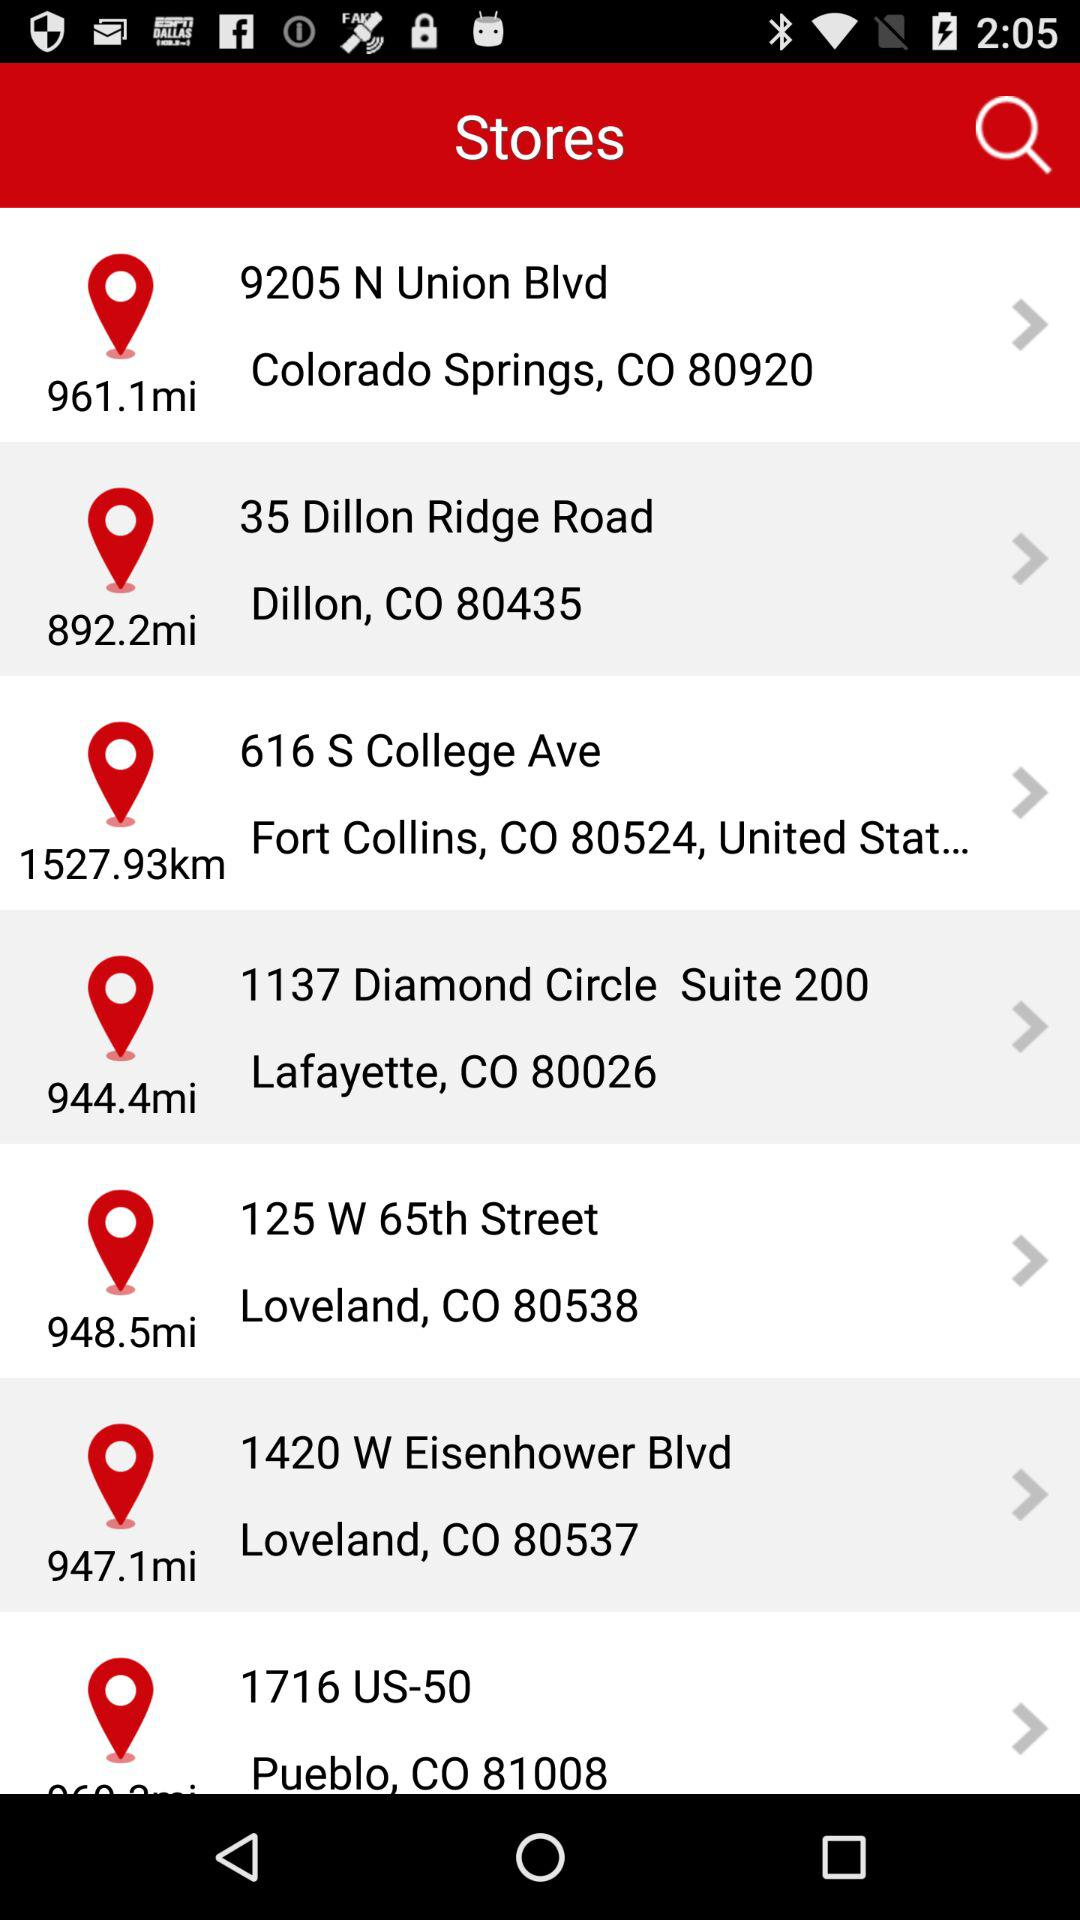Which store is located closest to Colorado Springs?
Answer the question using a single word or phrase. 9205 N Union Blvd 